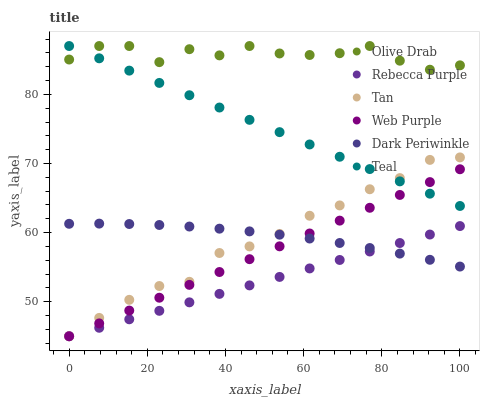Does Rebecca Purple have the minimum area under the curve?
Answer yes or no. Yes. Does Olive Drab have the maximum area under the curve?
Answer yes or no. Yes. Does Teal have the minimum area under the curve?
Answer yes or no. No. Does Teal have the maximum area under the curve?
Answer yes or no. No. Is Rebecca Purple the smoothest?
Answer yes or no. Yes. Is Olive Drab the roughest?
Answer yes or no. Yes. Is Teal the smoothest?
Answer yes or no. No. Is Teal the roughest?
Answer yes or no. No. Does Web Purple have the lowest value?
Answer yes or no. Yes. Does Teal have the lowest value?
Answer yes or no. No. Does Olive Drab have the highest value?
Answer yes or no. Yes. Does Rebecca Purple have the highest value?
Answer yes or no. No. Is Rebecca Purple less than Teal?
Answer yes or no. Yes. Is Olive Drab greater than Web Purple?
Answer yes or no. Yes. Does Web Purple intersect Dark Periwinkle?
Answer yes or no. Yes. Is Web Purple less than Dark Periwinkle?
Answer yes or no. No. Is Web Purple greater than Dark Periwinkle?
Answer yes or no. No. Does Rebecca Purple intersect Teal?
Answer yes or no. No. 